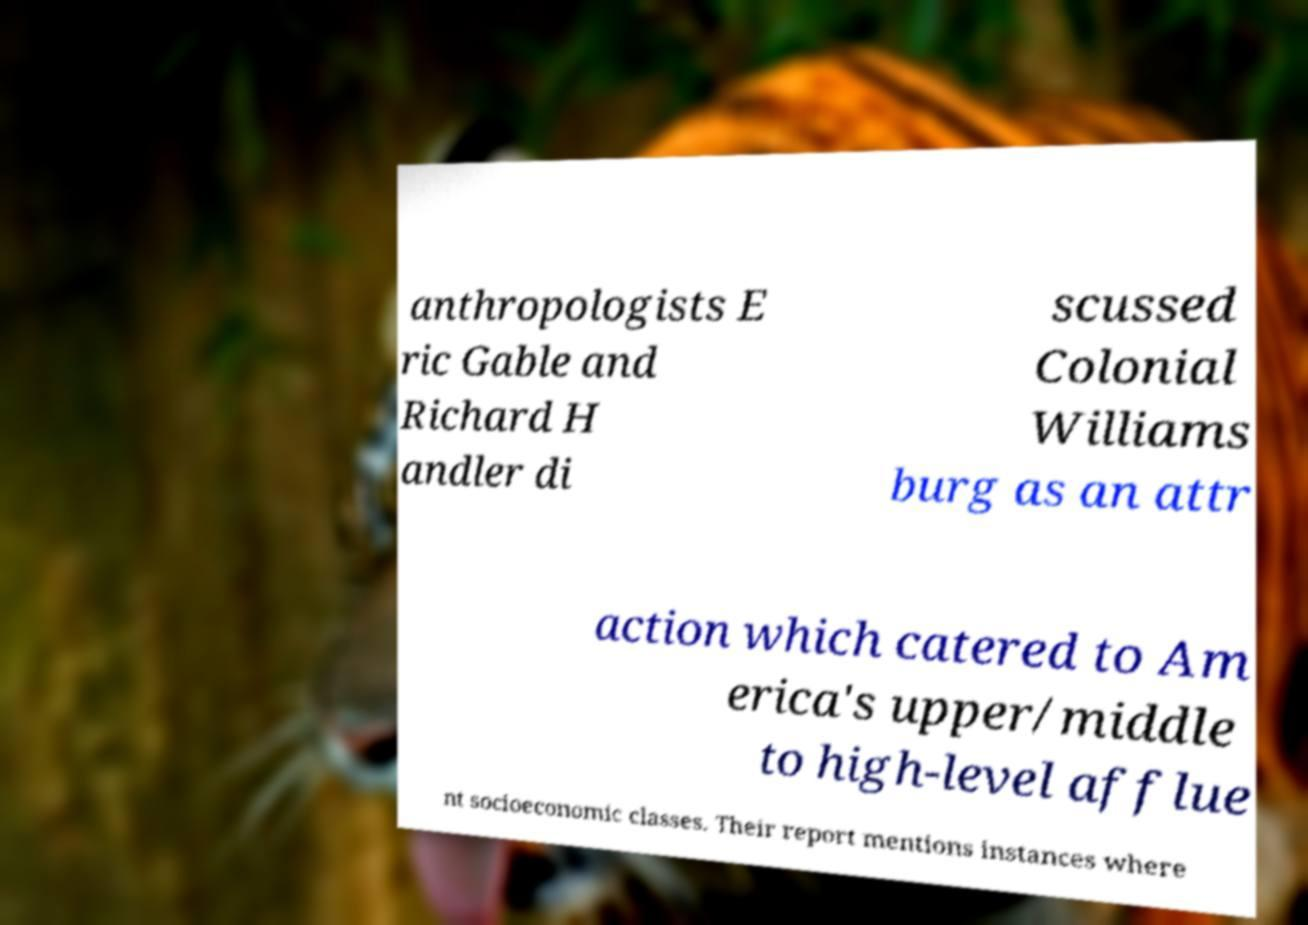I need the written content from this picture converted into text. Can you do that? anthropologists E ric Gable and Richard H andler di scussed Colonial Williams burg as an attr action which catered to Am erica's upper/middle to high-level afflue nt socioeconomic classes. Their report mentions instances where 